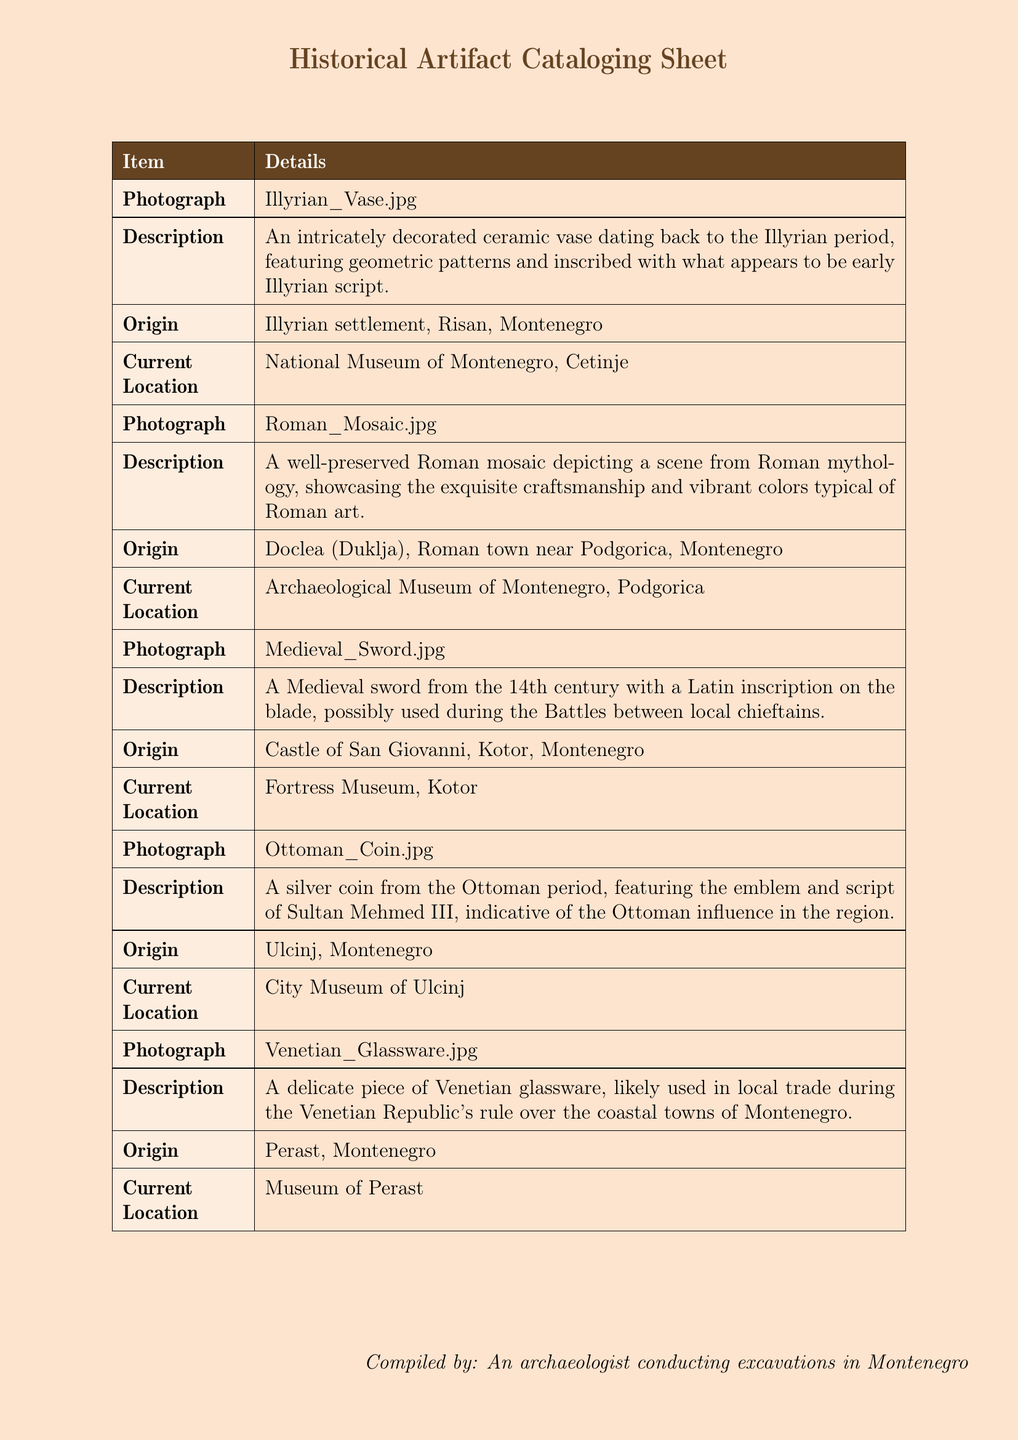What is the first artifact listed? The first artifact in the document is an Illyrian vase, as indicated in the table.
Answer: Illyrian vase What is the origin of the Roman mosaic? The origin of the Roman mosaic is stated as being from Doclea, a Roman town near Podgorica, Montenegro.
Answer: Doclea Where is the Medieval sword currently located? The current location of the Medieval sword is specified to be the Fortress Museum in Kotor.
Answer: Fortress Museum, Kotor What period does the Ottoman coin belong to? The document explicitly mentions that the coin is from the Ottoman period.
Answer: Ottoman period Which artifact features a Latin inscription? The Medieval sword is noted for having a Latin inscription on its blade.
Answer: Medieval sword Which type of museum houses the Venetian glassware? The Venetian glassware is located in the Museum of Perast, as detailed in the document.
Answer: Museum of Perast What is the main theme of the artifacts displayed? The artifacts represent different historical periods and cultures that influenced Montenegro, ranging from Illyrian to Ottoman.
Answer: Historical periods and cultures How many artifacts are listed in total? The total number of artifacts displayed in the cataloging sheet is five.
Answer: Five What type of document is this? This document is a historical artifact cataloging sheet summarizing information about various historical artifacts.
Answer: Historical artifact cataloging sheet 